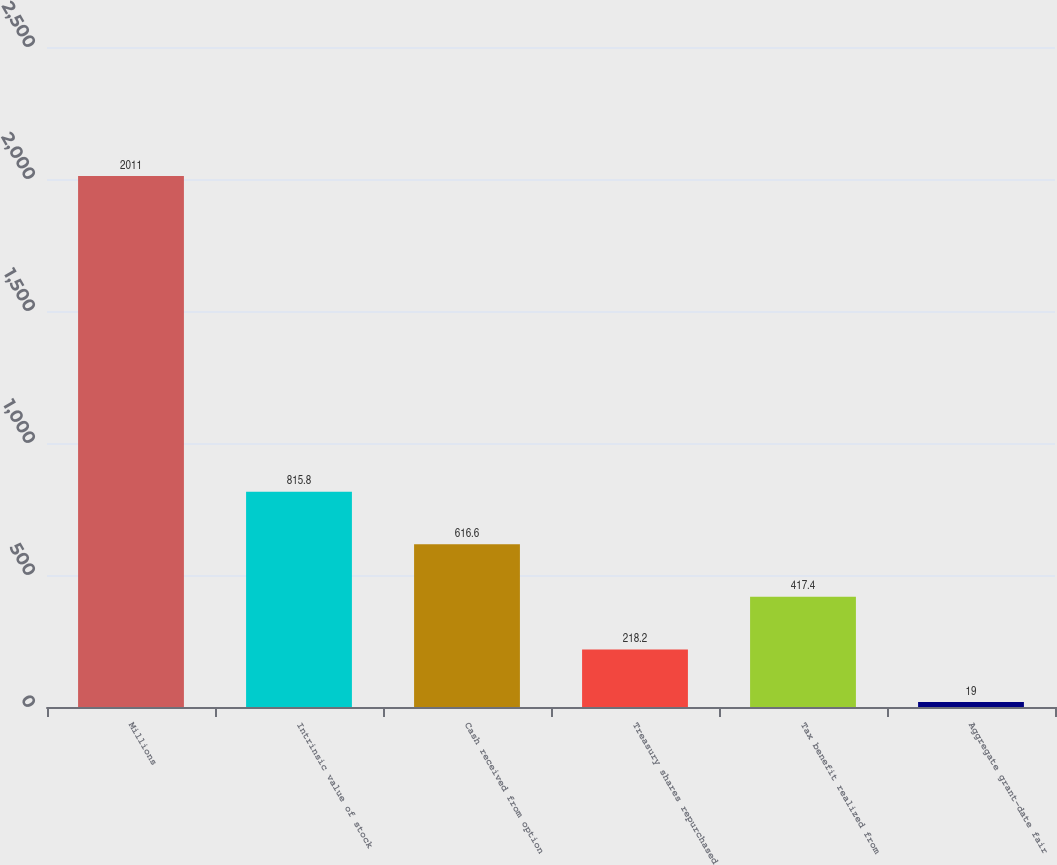Convert chart. <chart><loc_0><loc_0><loc_500><loc_500><bar_chart><fcel>Millions<fcel>Intrinsic value of stock<fcel>Cash received from option<fcel>Treasury shares repurchased<fcel>Tax benefit realized from<fcel>Aggregate grant-date fair<nl><fcel>2011<fcel>815.8<fcel>616.6<fcel>218.2<fcel>417.4<fcel>19<nl></chart> 